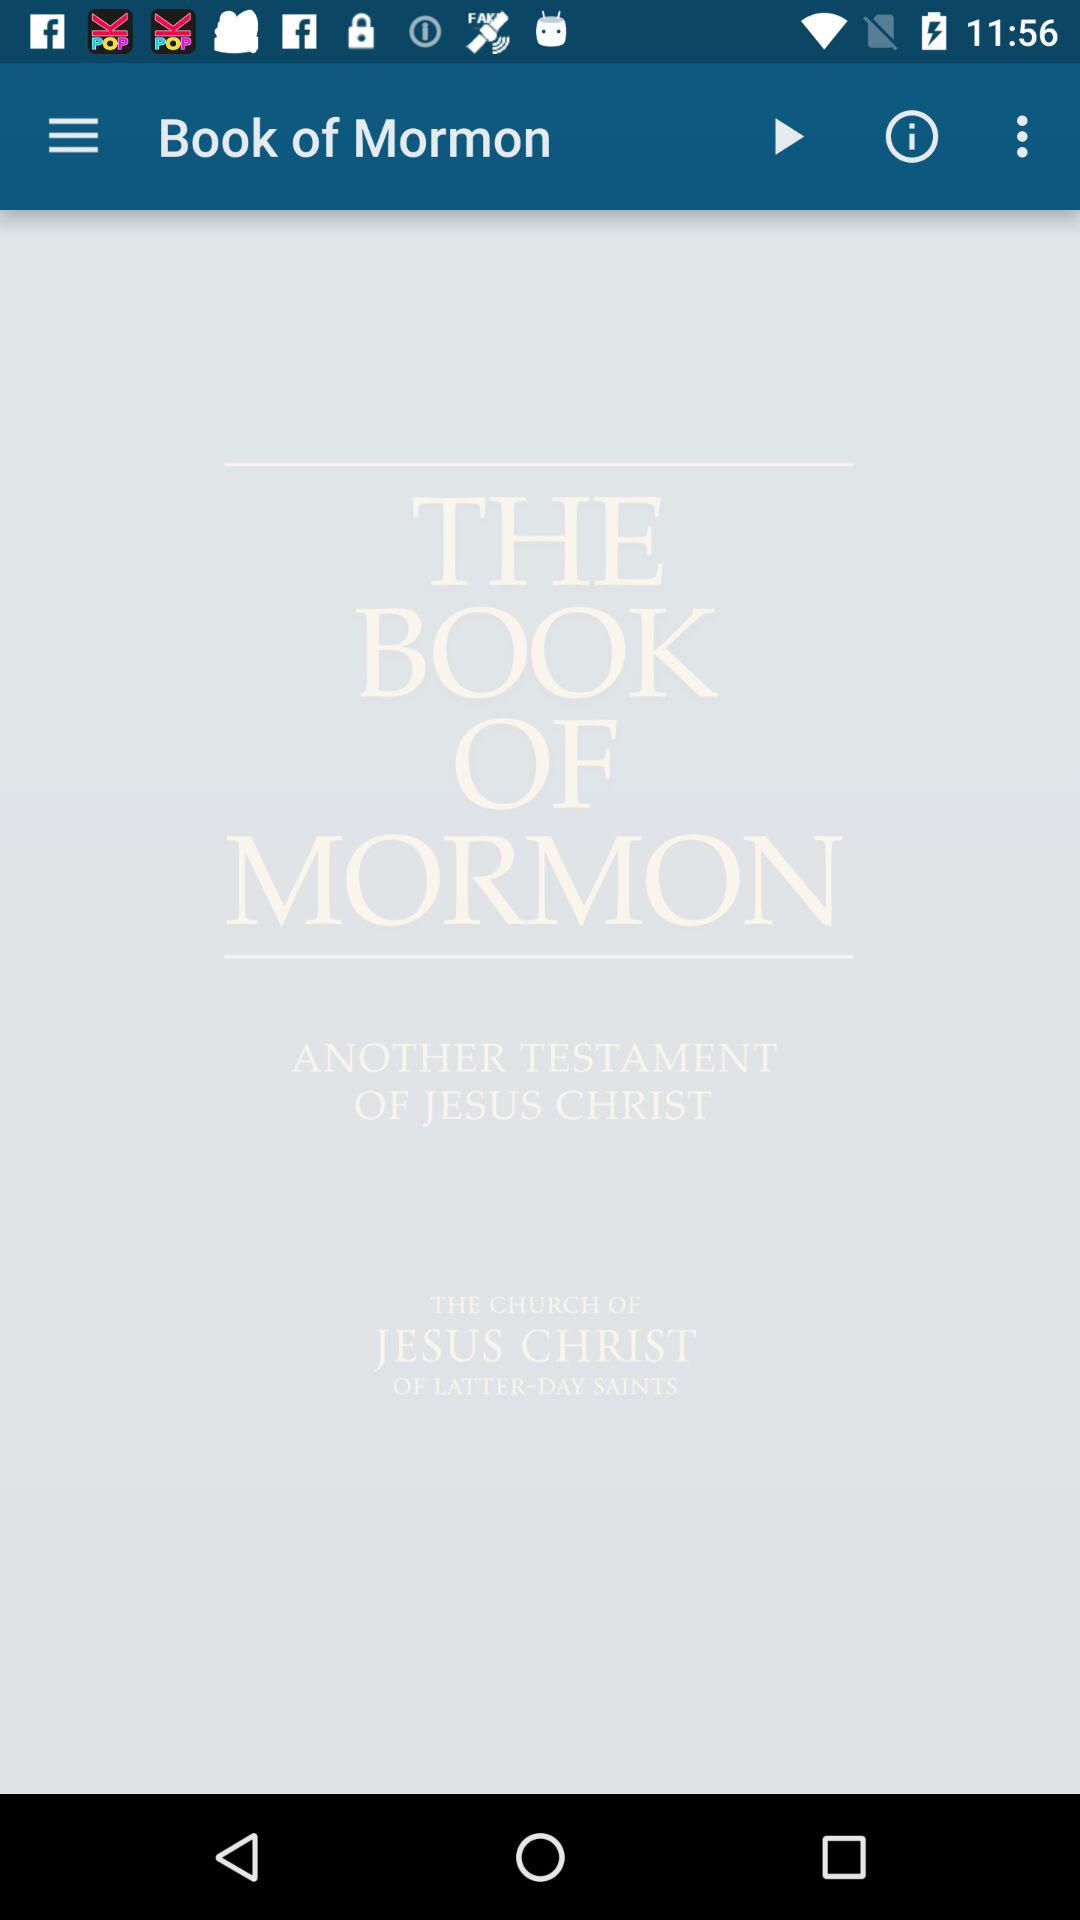What is the name of the book? The name of the book is "THE BOOK OF MORMON". 